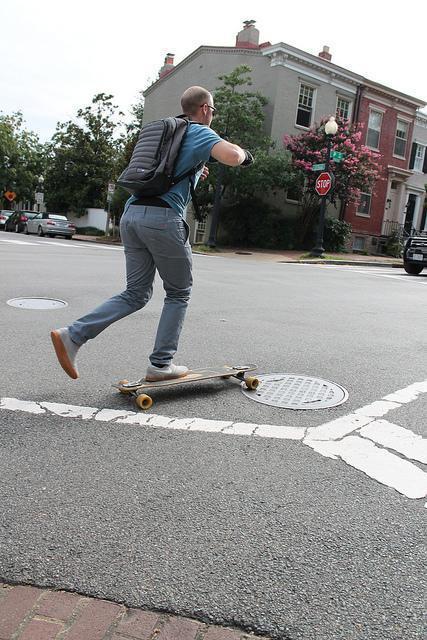How many people are there?
Give a very brief answer. 1. How many giraffes are facing the camera?
Give a very brief answer. 0. 